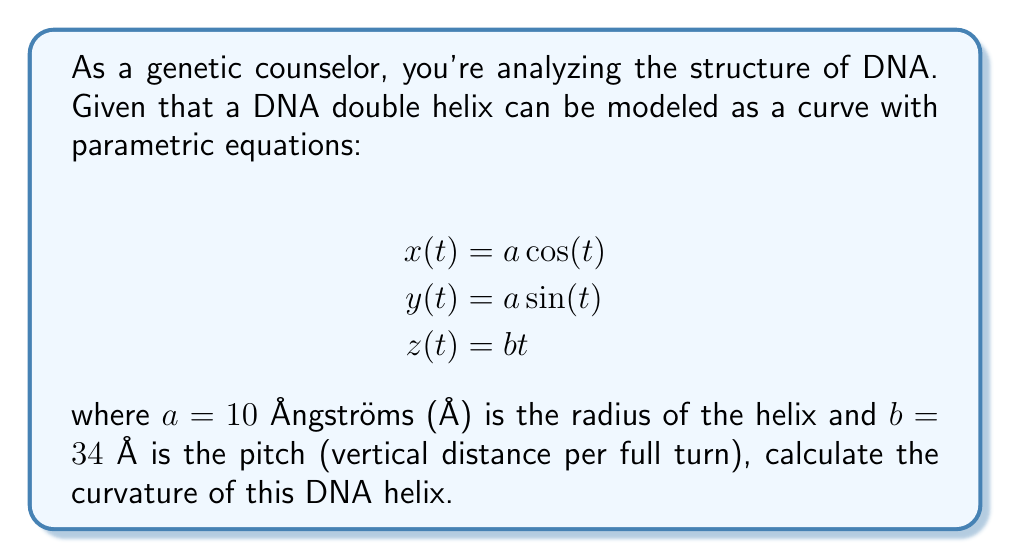Help me with this question. To calculate the curvature of the DNA helix, we'll follow these steps:

1) The curvature $\kappa$ of a space curve is given by:

   $$\kappa = \frac{|\mathbf{r}'(t) \times \mathbf{r}''(t)|}{|\mathbf{r}'(t)|^3}$$

   where $\mathbf{r}(t) = (x(t), y(t), z(t))$ is the position vector.

2) Let's calculate $\mathbf{r}'(t)$ and $\mathbf{r}''(t)$:

   $$\mathbf{r}'(t) = (-a\sin(t), a\cos(t), b)$$
   $$\mathbf{r}''(t) = (-a\cos(t), -a\sin(t), 0)$$

3) Now, let's calculate $\mathbf{r}'(t) \times \mathbf{r}''(t)$:

   $$\mathbf{r}'(t) \times \mathbf{r}''(t) = (ab\sin(t), -ab\cos(t), a^2)$$

4) The magnitude of this cross product is:

   $$|\mathbf{r}'(t) \times \mathbf{r}''(t)| = \sqrt{(ab\sin(t))^2 + (-ab\cos(t))^2 + (a^2)^2} = \sqrt{a^2b^2 + a^4}$$

5) The magnitude of $\mathbf{r}'(t)$ is:

   $$|\mathbf{r}'(t)| = \sqrt{a^2\sin^2(t) + a^2\cos^2(t) + b^2} = \sqrt{a^2 + b^2}$$

6) Substituting into the curvature formula:

   $$\kappa = \frac{\sqrt{a^2b^2 + a^4}}{(a^2 + b^2)^{3/2}}$$

7) Now, let's substitute the given values: $a = 10$ Å and $b = 34$ Å:

   $$\kappa = \frac{\sqrt{10^2 \cdot 34^2 + 10^4}}{(10^2 + 34^2)^{3/2}} = \frac{\sqrt{115600}}{1256^{3/2}} \approx 0.0266 \text{ Å}^{-1}$$
Answer: $0.0266 \text{ Å}^{-1}$ 